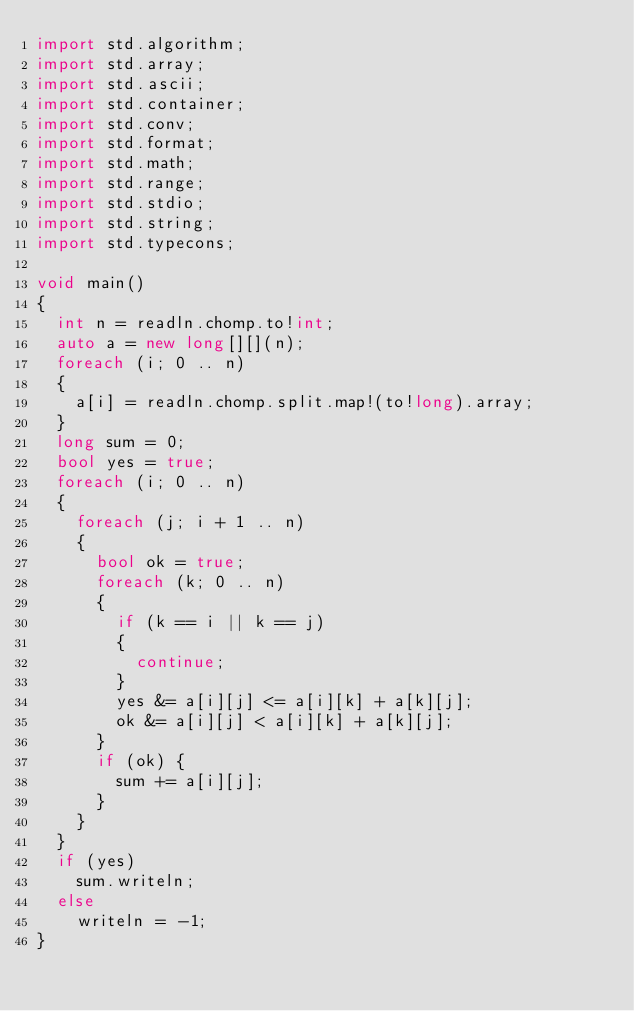<code> <loc_0><loc_0><loc_500><loc_500><_D_>import std.algorithm;
import std.array;
import std.ascii;
import std.container;
import std.conv;
import std.format;
import std.math;
import std.range;
import std.stdio;
import std.string;
import std.typecons;

void main()
{
  int n = readln.chomp.to!int;
  auto a = new long[][](n);
  foreach (i; 0 .. n)
  {
    a[i] = readln.chomp.split.map!(to!long).array;
  }
  long sum = 0;
  bool yes = true;
  foreach (i; 0 .. n)
  {
    foreach (j; i + 1 .. n)
    {
      bool ok = true;
      foreach (k; 0 .. n)
      {
        if (k == i || k == j)
        {
          continue;
        }
        yes &= a[i][j] <= a[i][k] + a[k][j];
        ok &= a[i][j] < a[i][k] + a[k][j];
      }
      if (ok) {
        sum += a[i][j];
      }
    }
  }
  if (yes)
    sum.writeln;
  else
    writeln = -1;
}
</code> 